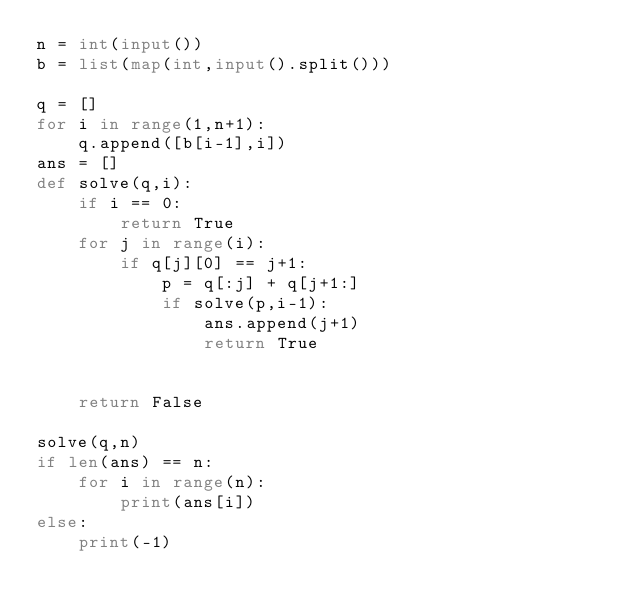<code> <loc_0><loc_0><loc_500><loc_500><_Python_>n = int(input())
b = list(map(int,input().split()))

q = []
for i in range(1,n+1):
    q.append([b[i-1],i])
ans = []
def solve(q,i):
    if i == 0:
        return True
    for j in range(i):
        if q[j][0] == j+1:
            p = q[:j] + q[j+1:]
            if solve(p,i-1):
                ans.append(j+1)
                return True


    return False

solve(q,n)
if len(ans) == n:
    for i in range(n):
        print(ans[i])
else:
    print(-1)</code> 